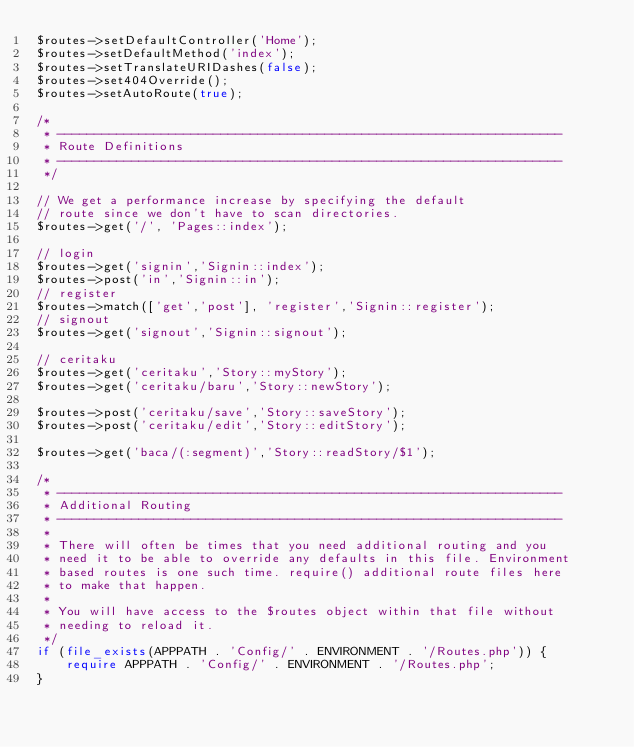<code> <loc_0><loc_0><loc_500><loc_500><_PHP_>$routes->setDefaultController('Home');
$routes->setDefaultMethod('index');
$routes->setTranslateURIDashes(false);
$routes->set404Override();
$routes->setAutoRoute(true);

/*
 * --------------------------------------------------------------------
 * Route Definitions
 * --------------------------------------------------------------------
 */

// We get a performance increase by specifying the default
// route since we don't have to scan directories.
$routes->get('/', 'Pages::index');

// login
$routes->get('signin','Signin::index');
$routes->post('in','Signin::in');
// register
$routes->match(['get','post'], 'register','Signin::register');
// signout
$routes->get('signout','Signin::signout');

// ceritaku
$routes->get('ceritaku','Story::myStory');
$routes->get('ceritaku/baru','Story::newStory');

$routes->post('ceritaku/save','Story::saveStory');
$routes->post('ceritaku/edit','Story::editStory');

$routes->get('baca/(:segment)','Story::readStory/$1');

/*
 * --------------------------------------------------------------------
 * Additional Routing
 * --------------------------------------------------------------------
 *
 * There will often be times that you need additional routing and you
 * need it to be able to override any defaults in this file. Environment
 * based routes is one such time. require() additional route files here
 * to make that happen.
 *
 * You will have access to the $routes object within that file without
 * needing to reload it.
 */
if (file_exists(APPPATH . 'Config/' . ENVIRONMENT . '/Routes.php')) {
    require APPPATH . 'Config/' . ENVIRONMENT . '/Routes.php';
}</code> 